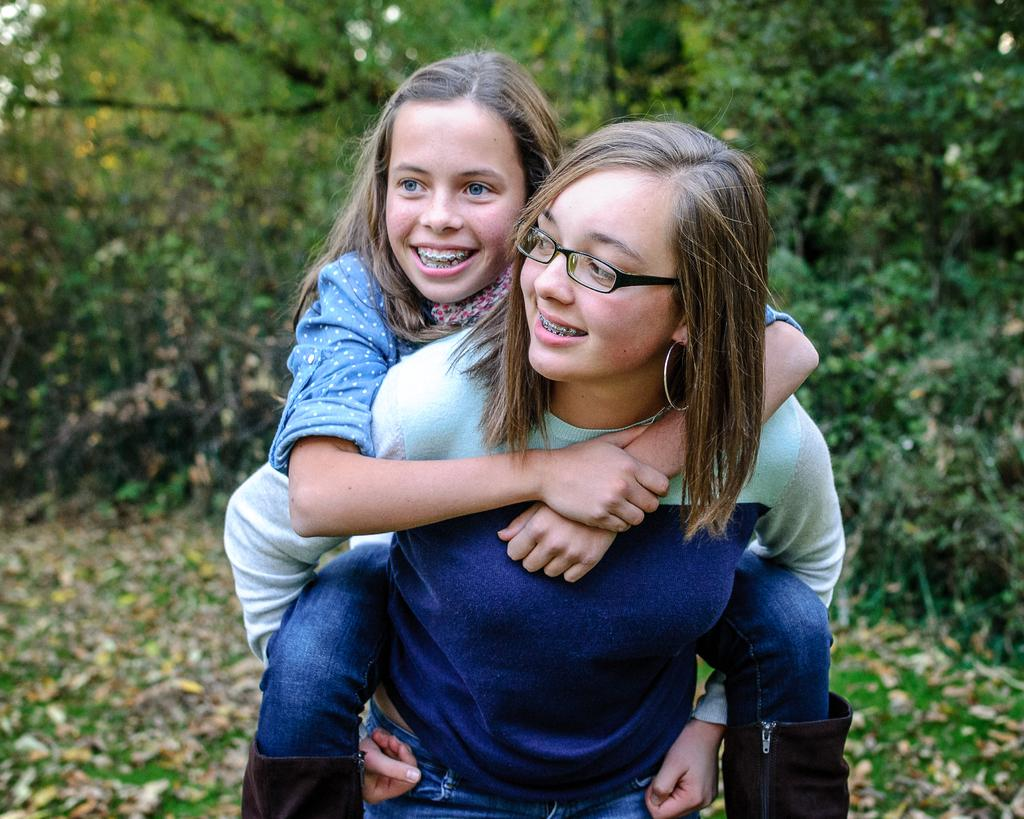How many people are in the image? There are two people in the front of the image. What are the expressions on the faces of the people in the image? The two people are smiling. What can be seen in the background of the image? The background of the image is blurry, and there are trees visible. What type of society can be seen interacting with the coast in the image? There is no coast or society present in the image; it features two people smiling in the foreground and a blurry background with trees. 